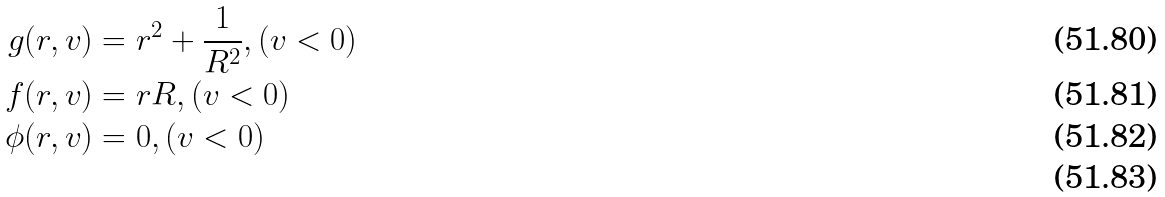<formula> <loc_0><loc_0><loc_500><loc_500>g ( r , v ) & = r ^ { 2 } + \frac { 1 } { R ^ { 2 } } , ( v < 0 ) \\ f ( r , v ) & = r R , ( v < 0 ) \\ \phi ( r , v ) & = 0 , ( v < 0 ) \\</formula> 